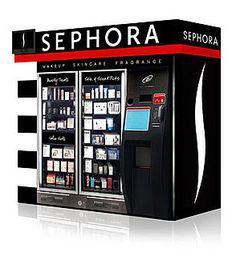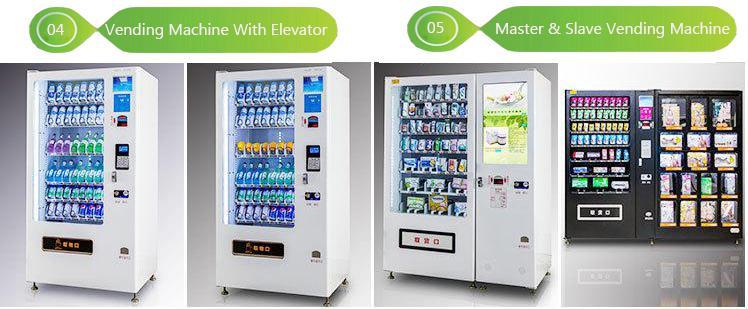The first image is the image on the left, the second image is the image on the right. Assess this claim about the two images: "There is a kiosk with people nearby.". Correct or not? Answer yes or no. No. 